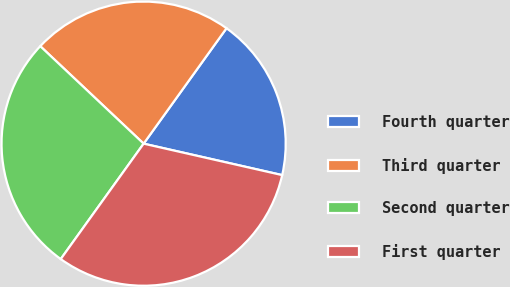<chart> <loc_0><loc_0><loc_500><loc_500><pie_chart><fcel>Fourth quarter<fcel>Third quarter<fcel>Second quarter<fcel>First quarter<nl><fcel>18.64%<fcel>22.88%<fcel>27.12%<fcel>31.36%<nl></chart> 